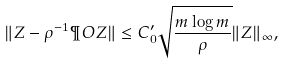<formula> <loc_0><loc_0><loc_500><loc_500>\| Z - \rho ^ { - 1 } \P O Z \| \leq C _ { 0 } ^ { \prime } \sqrt { \frac { m \log m } { \rho } } \| Z \| _ { \infty } ,</formula> 